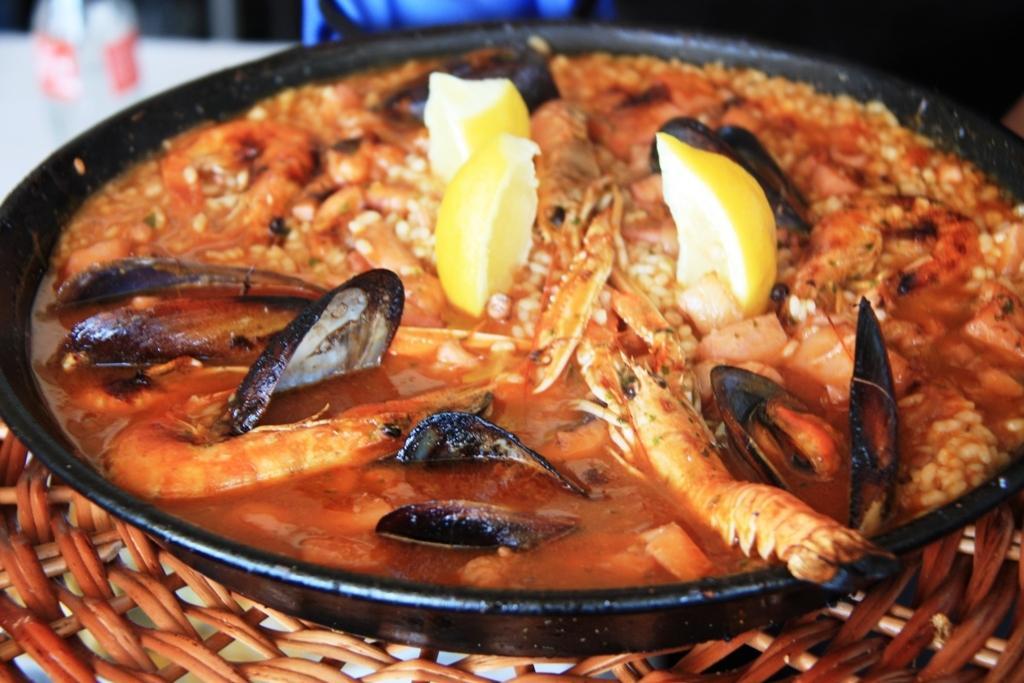In one or two sentences, can you explain what this image depicts? In this image we can see the black color bowl with food item is kept on the wooden surface. The background of the image is slightly blurred, where we can see the bottle is kept on the white color surface. 